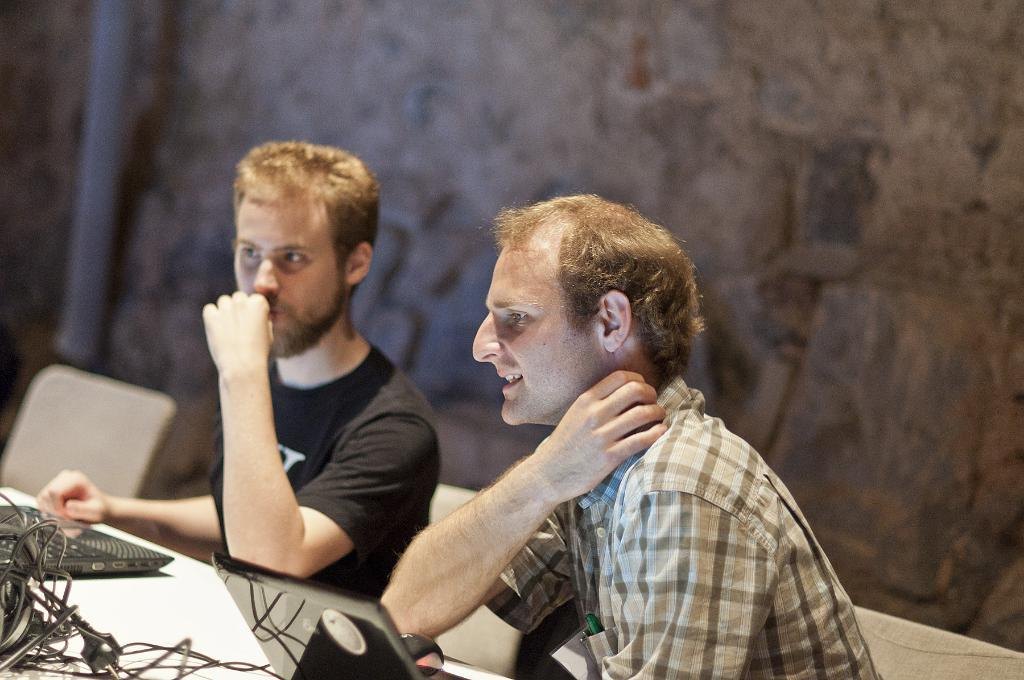How many people are present in the image? There are two persons in the image. What are the persons sitting on? There are chairs in the image. What electronic devices can be seen in the image? There are laptops in the image. What else is present in the image besides the people and laptops? Wires are visible in the image, and there are other objects as well. What can be seen in the background of the image? There is a wall in the background of the image. What type of letter is being cut with scissors in the image? There is no letter or scissors present in the image. What items are on the list that is visible in the image? There is no list present in the image. 